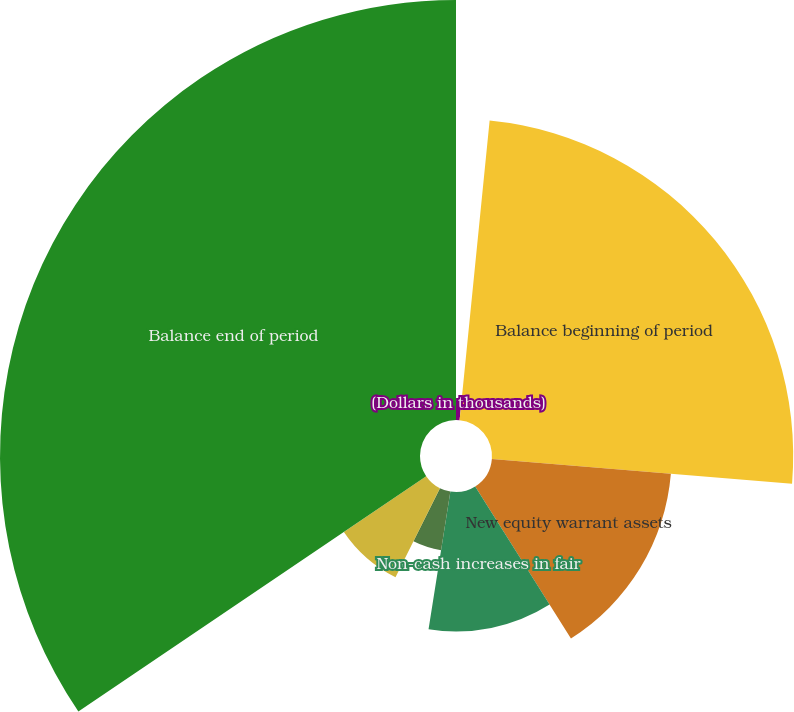Convert chart to OTSL. <chart><loc_0><loc_0><loc_500><loc_500><pie_chart><fcel>(Dollars in thousands)<fcel>Balance beginning of period<fcel>New equity warrant assets<fcel>Non-cash increases in fair<fcel>Exercised equity warrant<fcel>Terminated equity warrant<fcel>Balance end of period<nl><fcel>1.59%<fcel>24.72%<fcel>14.74%<fcel>11.45%<fcel>4.87%<fcel>8.16%<fcel>34.47%<nl></chart> 